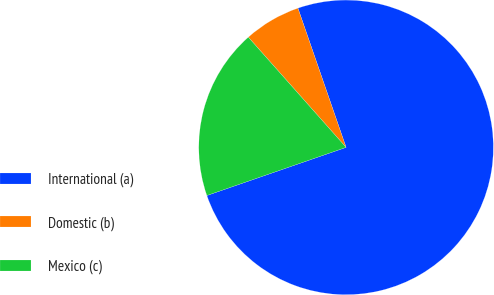Convert chart to OTSL. <chart><loc_0><loc_0><loc_500><loc_500><pie_chart><fcel>International (a)<fcel>Domestic (b)<fcel>Mexico (c)<nl><fcel>75.0%<fcel>6.25%<fcel>18.75%<nl></chart> 